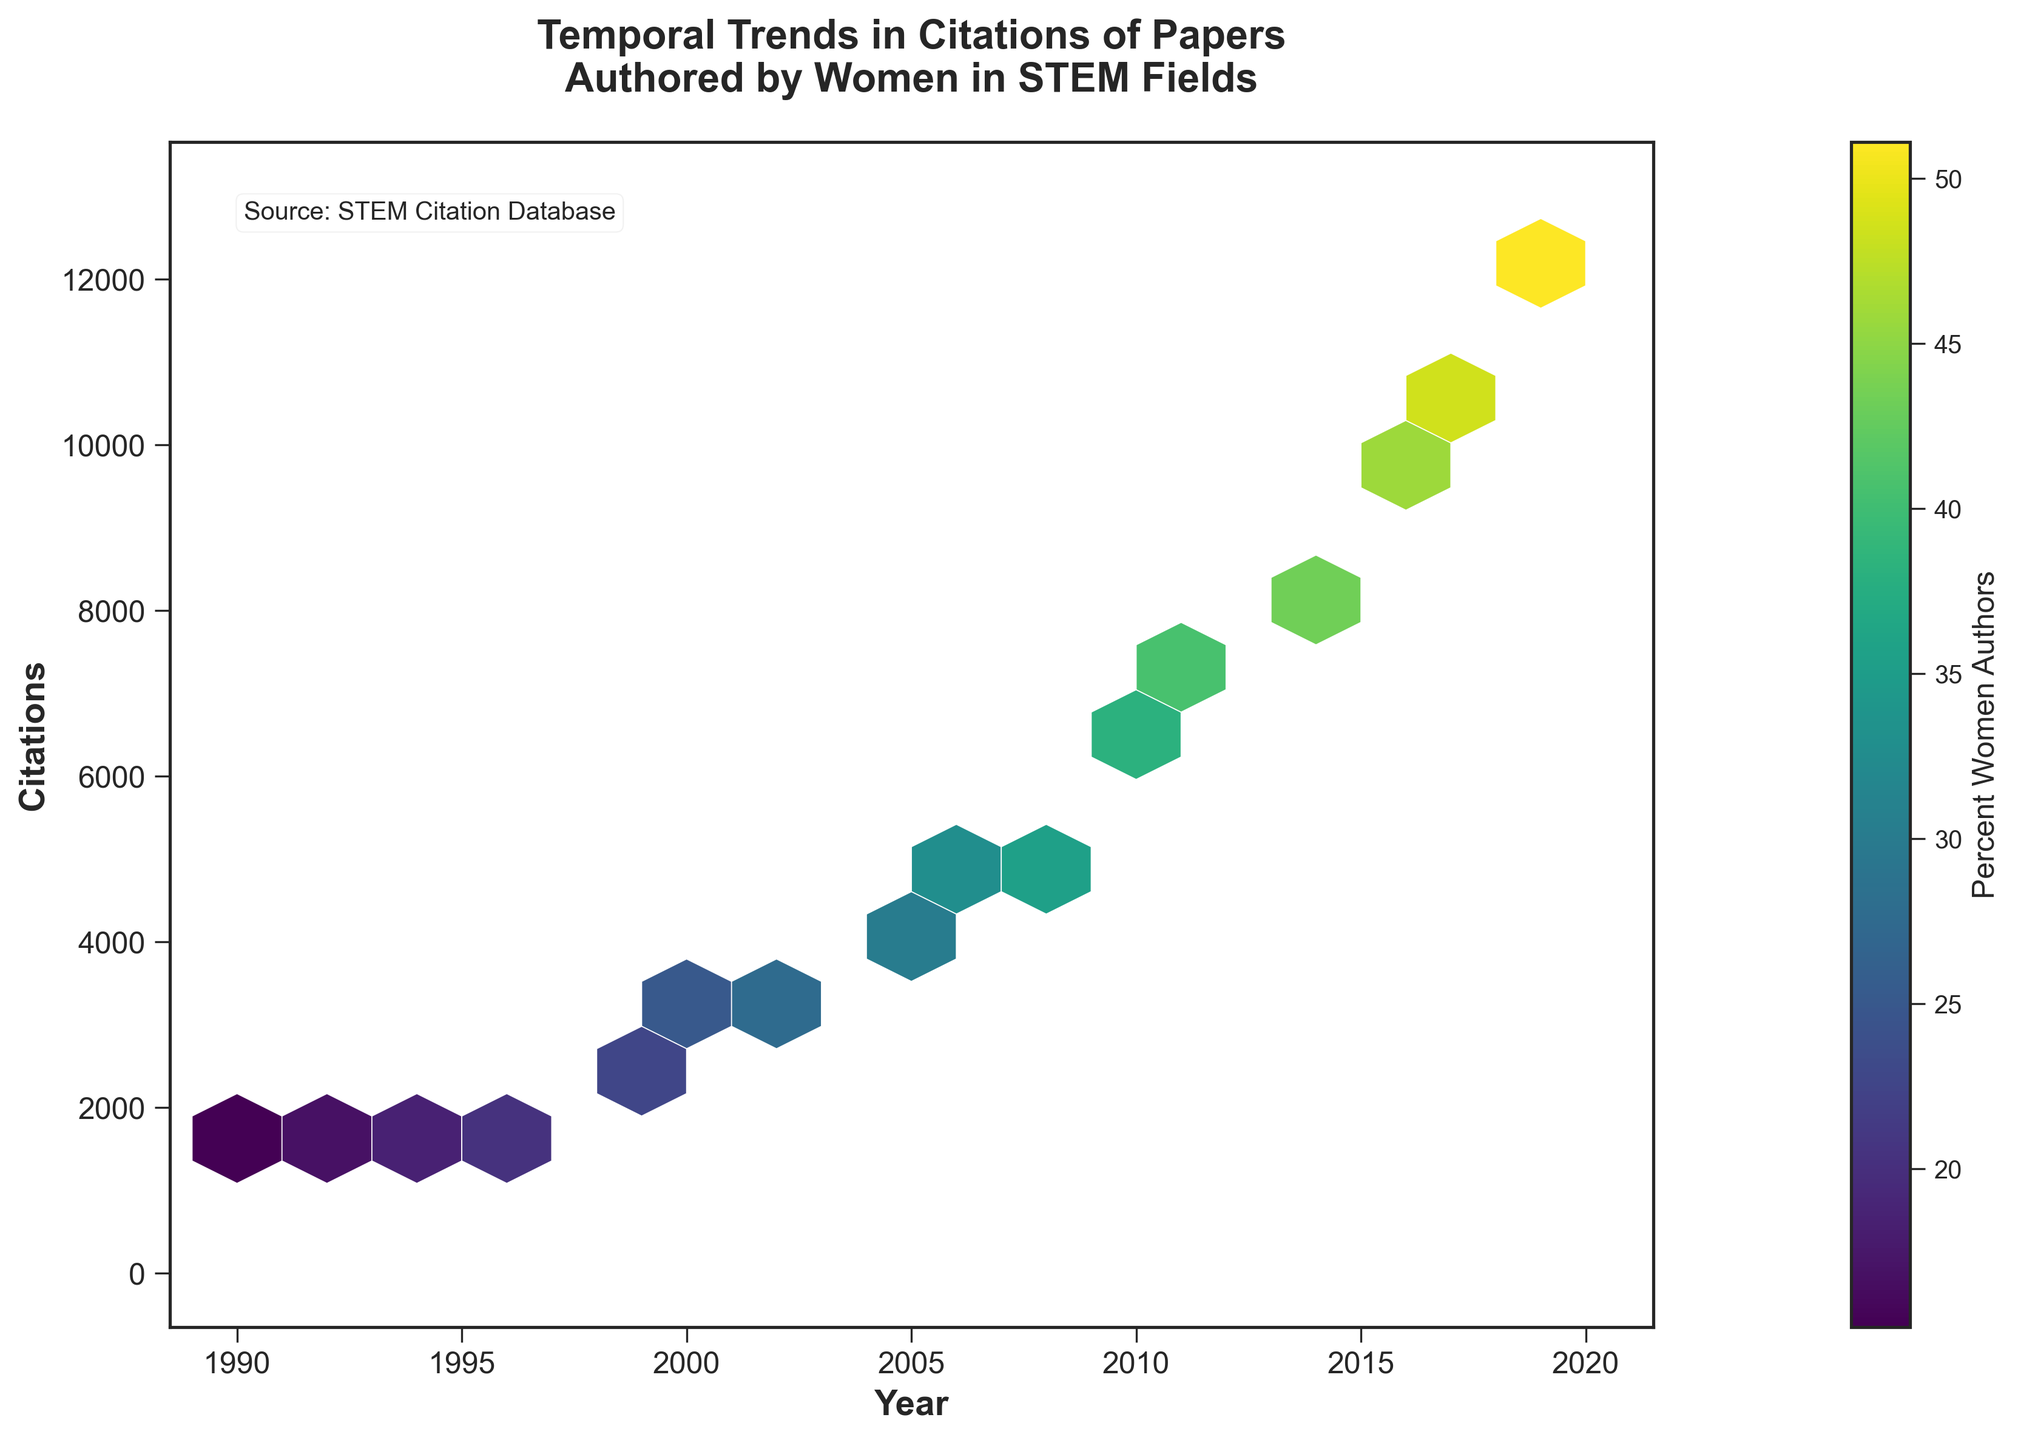What is the title of the plot? The title is located at the top center of the plot, clearly indicating the focus of the plot. It reads "Temporal Trends in Citations of Papers Authored by Women in STEM Fields".
Answer: Temporal Trends in Citations of Papers Authored by Women in STEM Fields What are the x-axis and y-axis labels? The x-axis label, found horizontally at the bottom of the plot, is "Year". The y-axis label, found vertically along the left side of the plot, is "Citations".
Answer: Year and Citations What does the color represent in the hexbin plot? The color in the hexbin plot represents the percentage of women authors of the papers. This is indicated by the color bar to the right of the plot with the label "Percent Women Authors".
Answer: Percent Women Authors How does the number of citations change over time? To observe the trend, look along the x-axis (Year) and y-axis (Citations). You will see that as the years progress from 1990 to 2020, the number of citations generally increases.
Answer: Increases Which year has the highest percentage of women authors? Look at the color bar and identify the hexagons with the darkest color, then check the corresponding year on the x-axis. The darkest color indicates the highest percentage and corresponds to the year 2020.
Answer: 2020 What is the range of years covered in the plot? Refer to the x-axis labels, which begin at 1990 and end at 2020, indicating the range of years covered in the plot.
Answer: 1990 to 2020 Between 2000 and 2010, how does the average number of citations change? Check the y-values for years 2000 and 2010 to see the trend. In 2000, citations are about 2780, and in 2010, they are about 6130. Calculating the difference shows a significant increase.
Answer: Increases significantly Is there a correlation between the number of citations and the percentage of women authors? Observing the color pattern vertically along the y-axis, there is a trend that as the number of citations increases, the color becomes darker (indicating a higher percentage of women authors), suggesting a positive correlation.
Answer: Yes Does the year 1998 show more or fewer citations compared to the year 2002? Identify the position of the hexbin cells for years 1998 and 2002. The y-value for 1998 is approximately 2320, while for 2002, it is around 3250, which shows that 2002 has more citations.
Answer: Fewer What is the percent range of women authors according to the color bar? The color bar to the right shows a continuous scale ranging from approximately 15% to 51%, indicating the percentage range of women authors.
Answer: 15% to 51% 